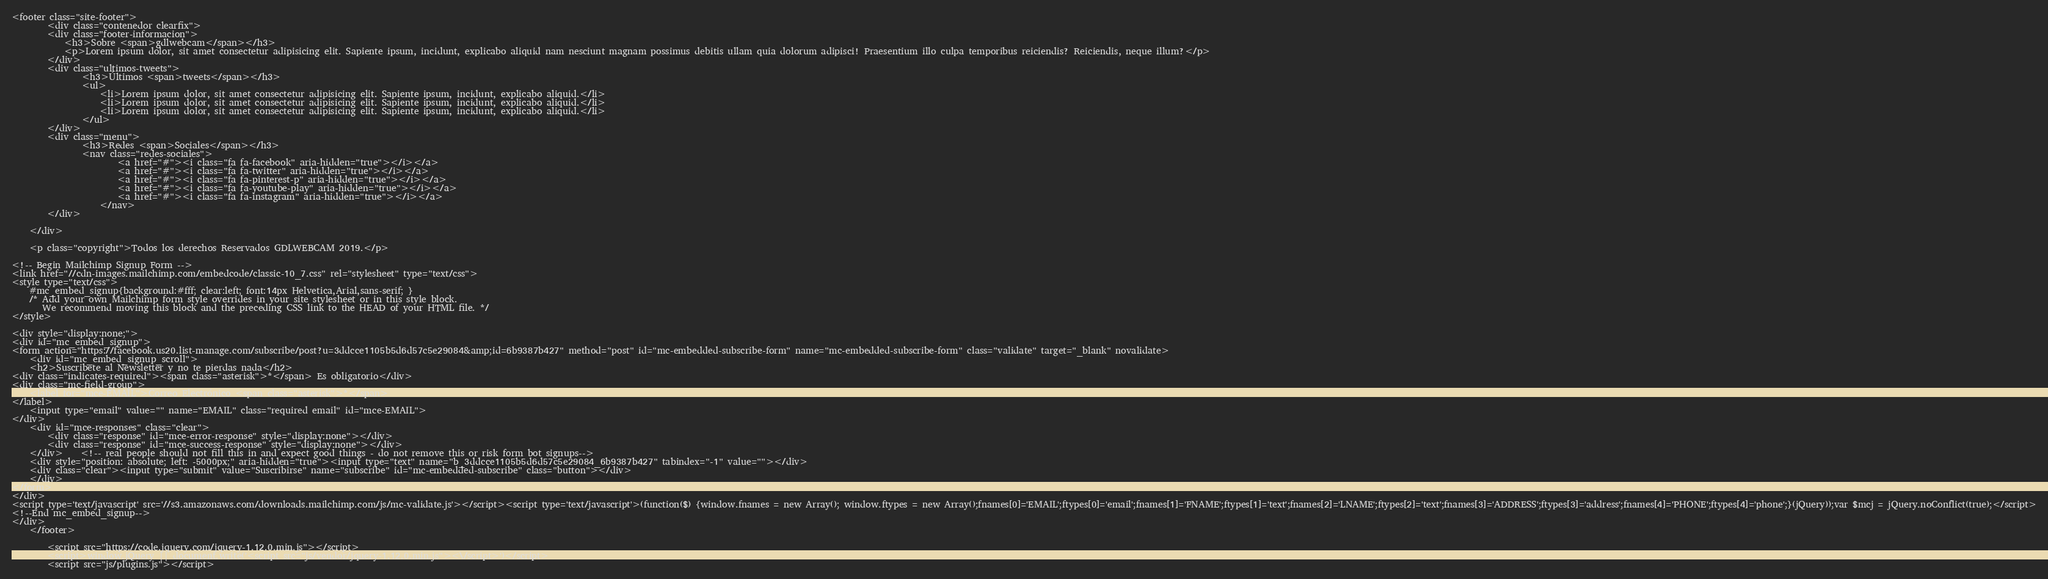<code> <loc_0><loc_0><loc_500><loc_500><_PHP_><footer class="site-footer">
        <div class="contenedor clearfix">
        <div class="footer-informacion">
            <h3>Sobre <span>gdlwebcam</span></h3>
            <p>Lorem ipsum dolor, sit amet consectetur adipisicing elit. Sapiente ipsum, incidunt, explicabo aliquid nam nesciunt magnam possimus debitis ullam quia dolorum adipisci! Praesentium illo culpa temporibus reiciendis? Reiciendis, neque illum?</p>
        </div>
        <div class="ultimos-tweets">
                <h3>Últimos <span>tweets</span></h3>
                <ul>
                    <li>Lorem ipsum dolor, sit amet consectetur adipisicing elit. Sapiente ipsum, incidunt, explicabo aliquid.</li>
                    <li>Lorem ipsum dolor, sit amet consectetur adipisicing elit. Sapiente ipsum, incidunt, explicabo aliquid.</li>
                    <li>Lorem ipsum dolor, sit amet consectetur adipisicing elit. Sapiente ipsum, incidunt, explicabo aliquid.</li>
                </ul>
        </div>
        <div class="menu">
                <h3>Redes <span>Sociales</span></h3>
                <nav class="redes-sociales">
                        <a href="#"><i class="fa fa-facebook" aria-hidden="true"></i></a>
                        <a href="#"><i class="fa fa-twitter" aria-hidden="true"></i></a>
                        <a href="#"><i class="fa fa-pinterest-p" aria-hidden="true"></i></a>
                        <a href="#"><i class="fa fa-youtube-play" aria-hidden="true"></i></a>
                        <a href="#"><i class="fa fa-instagram" aria-hidden="true"></i></a>
                    </nav>
        </div>

    </div>

    <p class="copyright">Todos los derechos Reservados GDLWEBCAM 2019.</p>

<!-- Begin Mailchimp Signup Form -->
<link href="//cdn-images.mailchimp.com/embedcode/classic-10_7.css" rel="stylesheet" type="text/css">
<style type="text/css">
	#mc_embed_signup{background:#fff; clear:left; font:14px Helvetica,Arial,sans-serif; }
	/* Add your own Mailchimp form style overrides in your site stylesheet or in this style block.
	   We recommend moving this block and the preceding CSS link to the HEAD of your HTML file. */
</style>

<div style="display:none;">
<div id="mc_embed_signup">
<form action="https://facebook.us20.list-manage.com/subscribe/post?u=3ddcce1105b5d6d57c5e29084&amp;id=6b9387b427" method="post" id="mc-embedded-subscribe-form" name="mc-embedded-subscribe-form" class="validate" target="_blank" novalidate>
    <div id="mc_embed_signup_scroll">
	<h2>Suscribete al Newsletter y no te pierdas nada</h2>
<div class="indicates-required"><span class="asterisk">*</span> Es obligatorio</div>
<div class="mc-field-group">
	<label for="mce-EMAIL">Correo Electrónico <span class="asterisk">*</span>
</label>
	<input type="email" value="" name="EMAIL" class="required email" id="mce-EMAIL">
</div>
	<div id="mce-responses" class="clear">
		<div class="response" id="mce-error-response" style="display:none"></div>
		<div class="response" id="mce-success-response" style="display:none"></div>
	</div>    <!-- real people should not fill this in and expect good things - do not remove this or risk form bot signups-->
    <div style="position: absolute; left: -5000px;" aria-hidden="true"><input type="text" name="b_3ddcce1105b5d6d57c5e29084_6b9387b427" tabindex="-1" value=""></div>
    <div class="clear"><input type="submit" value="Suscribirse" name="subscribe" id="mc-embedded-subscribe" class="button"></div>
    </div>
</form>
</div>
<script type='text/javascript' src='//s3.amazonaws.com/downloads.mailchimp.com/js/mc-validate.js'></script><script type='text/javascript'>(function($) {window.fnames = new Array(); window.ftypes = new Array();fnames[0]='EMAIL';ftypes[0]='email';fnames[1]='FNAME';ftypes[1]='text';fnames[2]='LNAME';ftypes[2]='text';fnames[3]='ADDRESS';ftypes[3]='address';fnames[4]='PHONE';ftypes[4]='phone';}(jQuery));var $mcj = jQuery.noConflict(true);</script>
<!--End mc_embed_signup-->
</div>
    </footer>

        <script src="https://code.jquery.com/jquery-1.12.0.min.js"></script>
        <script>window.jQuery || document.write('<script src="js/vendor/jquery-1.12.0.min.js"><\/script>')</script>
        <script src="js/plugins.js"></script></code> 